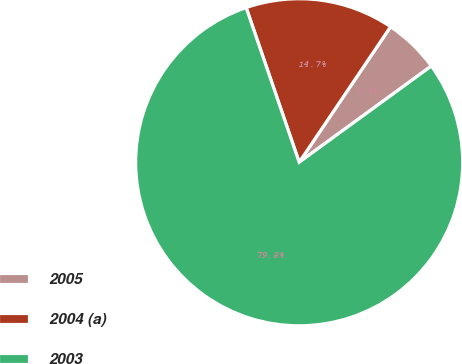Convert chart. <chart><loc_0><loc_0><loc_500><loc_500><pie_chart><fcel>2005<fcel>2004 (a)<fcel>2003<nl><fcel>5.54%<fcel>14.7%<fcel>79.76%<nl></chart> 